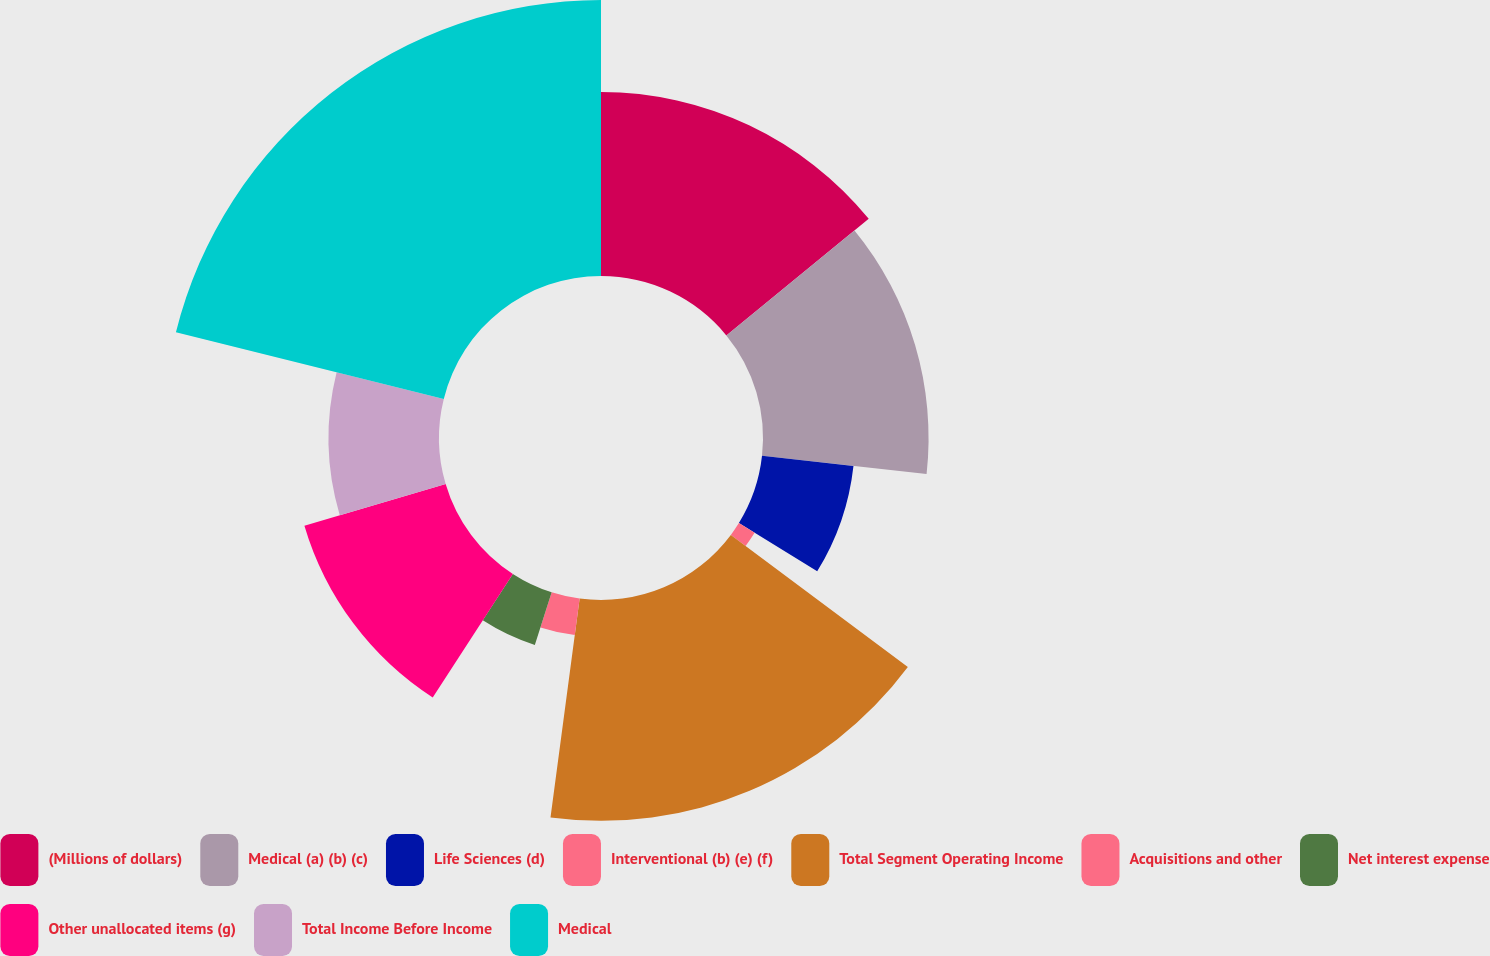Convert chart to OTSL. <chart><loc_0><loc_0><loc_500><loc_500><pie_chart><fcel>(Millions of dollars)<fcel>Medical (a) (b) (c)<fcel>Life Sciences (d)<fcel>Interventional (b) (e) (f)<fcel>Total Segment Operating Income<fcel>Acquisitions and other<fcel>Net interest expense<fcel>Other unallocated items (g)<fcel>Total Income Before Income<fcel>Medical<nl><fcel>14.08%<fcel>12.67%<fcel>7.04%<fcel>1.41%<fcel>16.9%<fcel>2.82%<fcel>4.23%<fcel>11.27%<fcel>8.45%<fcel>21.12%<nl></chart> 